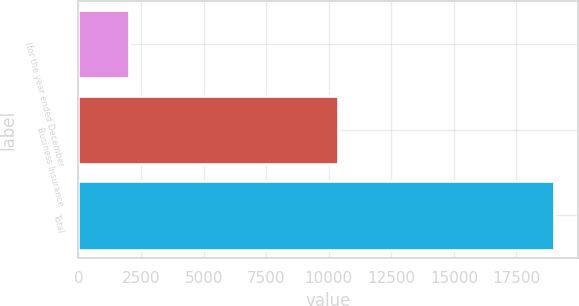Convert chart. <chart><loc_0><loc_0><loc_500><loc_500><bar_chart><fcel>(for the year ended December<fcel>Business Insurance<fcel>Total<nl><fcel>2004<fcel>10374<fcel>19011<nl></chart> 